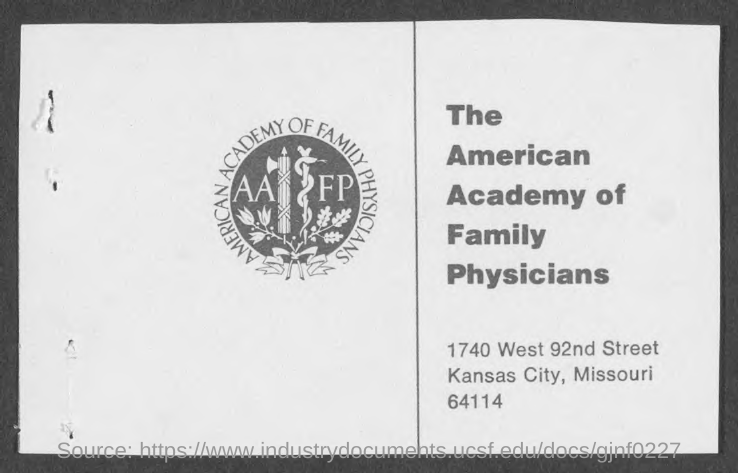Highlight a few significant elements in this photo. The acronym "AAFP" stands for "American Academy of Family Physicians. The American Academy of Family Physicians is located at 1740 WEST 92ND STREET in KANSAS CITY, MISSOURI. 